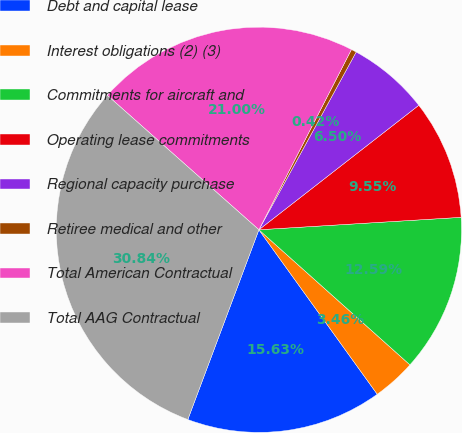Convert chart. <chart><loc_0><loc_0><loc_500><loc_500><pie_chart><fcel>Debt and capital lease<fcel>Interest obligations (2) (3)<fcel>Commitments for aircraft and<fcel>Operating lease commitments<fcel>Regional capacity purchase<fcel>Retiree medical and other<fcel>Total American Contractual<fcel>Total AAG Contractual<nl><fcel>15.63%<fcel>3.46%<fcel>12.59%<fcel>9.55%<fcel>6.5%<fcel>0.42%<fcel>21.0%<fcel>30.84%<nl></chart> 